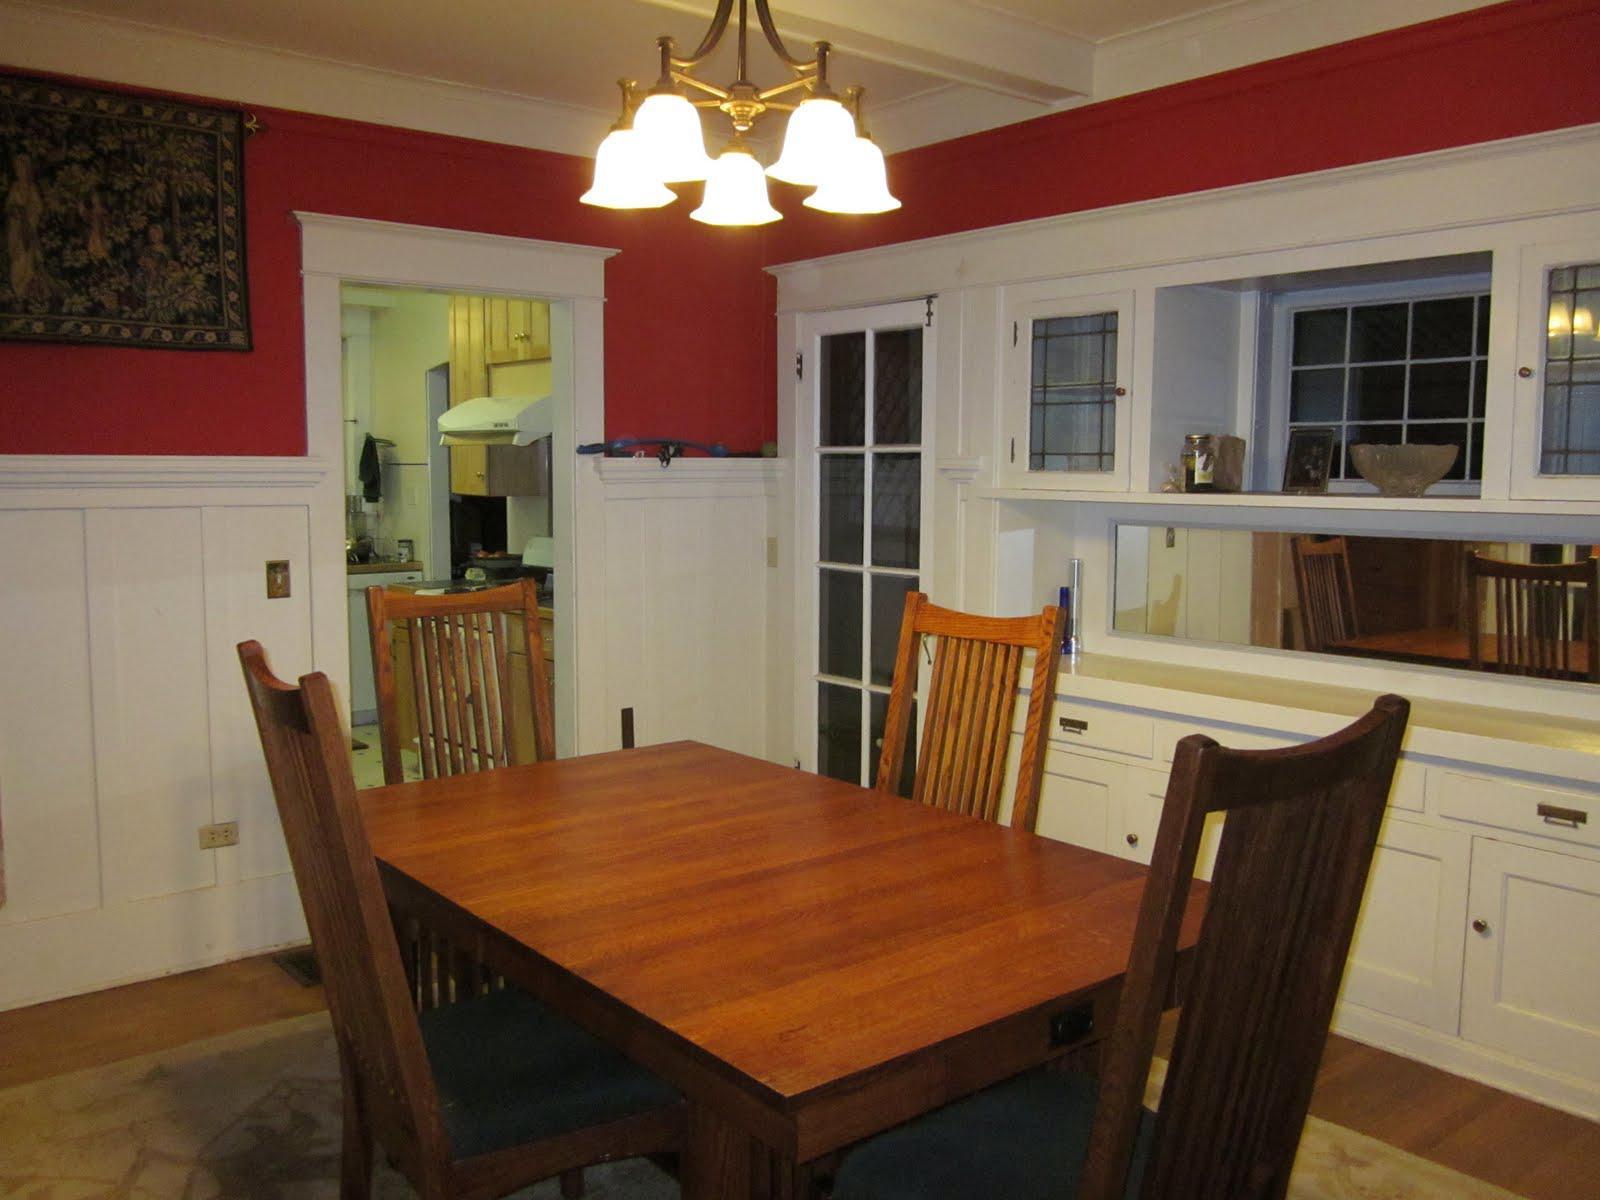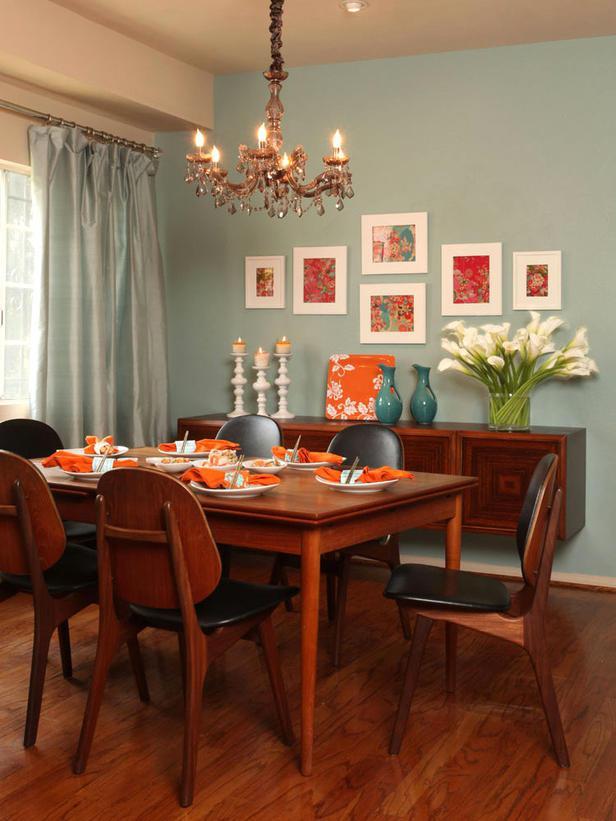The first image is the image on the left, the second image is the image on the right. Given the left and right images, does the statement "In at least one image there are three hanging light over a kitchen island." hold true? Answer yes or no. No. The first image is the image on the left, the second image is the image on the right. Assess this claim about the two images: "The left image features two bar stools pulled up to a counter with three lights hanging over it.". Correct or not? Answer yes or no. No. 